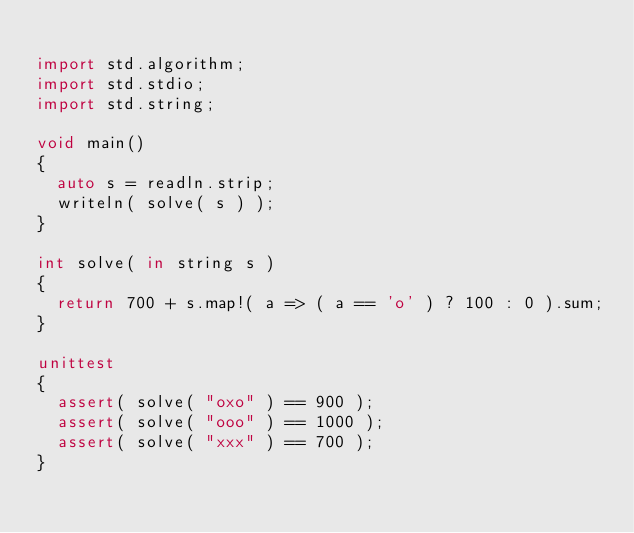Convert code to text. <code><loc_0><loc_0><loc_500><loc_500><_D_>
import std.algorithm;
import std.stdio;
import std.string;

void main()
{
	auto s = readln.strip;
	writeln( solve( s ) );
}

int solve( in string s )
{
	return 700 + s.map!( a => ( a == 'o' ) ? 100 : 0 ).sum;
}

unittest
{
	assert( solve( "oxo" ) == 900 );
	assert( solve( "ooo" ) == 1000 );
	assert( solve( "xxx" ) == 700 );
}
</code> 